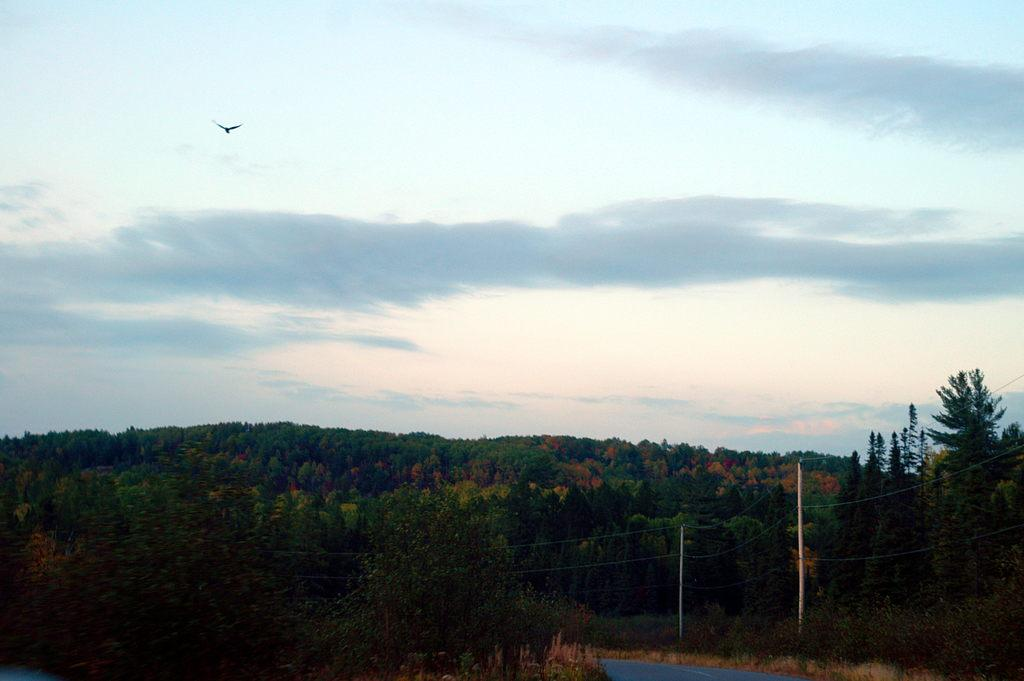What type of vegetation is present at the bottom of the image? There are many trees at the bottom of the image. What else can be seen at the bottom of the image? There are poles with wires at the bottom of the image. What is visible at the top of the image? There is a sky with clouds at the top of the image. What is flying in the sky at the top of the image? There is a bird flying in the sky at the top of the image. How does the bird control the movement of the clouds in the image? The bird does not control the movement of the clouds in the image; it is simply flying in the sky. What type of drink is being offered to the trees at the bottom of the image? There is no drink being offered to the trees in the image; the trees are stationary vegetation. 